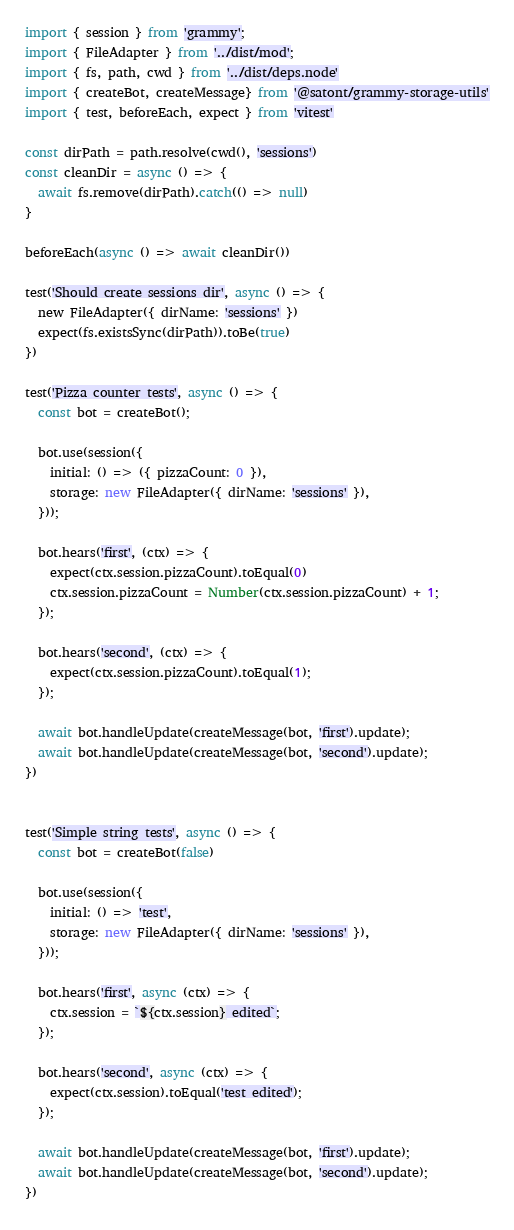Convert code to text. <code><loc_0><loc_0><loc_500><loc_500><_TypeScript_>
import { session } from 'grammy';
import { FileAdapter } from '../dist/mod';
import { fs, path, cwd } from '../dist/deps.node'
import { createBot, createMessage} from '@satont/grammy-storage-utils'
import { test, beforeEach, expect } from 'vitest'

const dirPath = path.resolve(cwd(), 'sessions')
const cleanDir = async () => {
  await fs.remove(dirPath).catch(() => null)
}

beforeEach(async () => await cleanDir())

test('Should create sessions dir', async () => {
  new FileAdapter({ dirName: 'sessions' })
  expect(fs.existsSync(dirPath)).toBe(true)
})

test('Pizza counter tests', async () => {
  const bot = createBot();

  bot.use(session({
    initial: () => ({ pizzaCount: 0 }),
    storage: new FileAdapter({ dirName: 'sessions' }),
  }));

  bot.hears('first', (ctx) => {
    expect(ctx.session.pizzaCount).toEqual(0)
    ctx.session.pizzaCount = Number(ctx.session.pizzaCount) + 1;
  });
  
  bot.hears('second', (ctx) => {
    expect(ctx.session.pizzaCount).toEqual(1);
  });
  
  await bot.handleUpdate(createMessage(bot, 'first').update);
  await bot.handleUpdate(createMessage(bot, 'second').update);
})
 

test('Simple string tests', async () => {
  const bot = createBot(false)

  bot.use(session({
    initial: () => 'test',
    storage: new FileAdapter({ dirName: 'sessions' }),
  }));

  bot.hears('first', async (ctx) => {
    ctx.session = `${ctx.session} edited`;
  });
  
  bot.hears('second', async (ctx) => {
    expect(ctx.session).toEqual('test edited');
  });
  
  await bot.handleUpdate(createMessage(bot, 'first').update);
  await bot.handleUpdate(createMessage(bot, 'second').update);
})</code> 